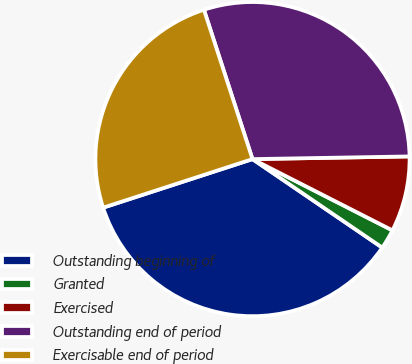Convert chart to OTSL. <chart><loc_0><loc_0><loc_500><loc_500><pie_chart><fcel>Outstanding beginning of<fcel>Granted<fcel>Exercised<fcel>Outstanding end of period<fcel>Exercisable end of period<nl><fcel>35.47%<fcel>2.03%<fcel>7.77%<fcel>29.73%<fcel>25.0%<nl></chart> 